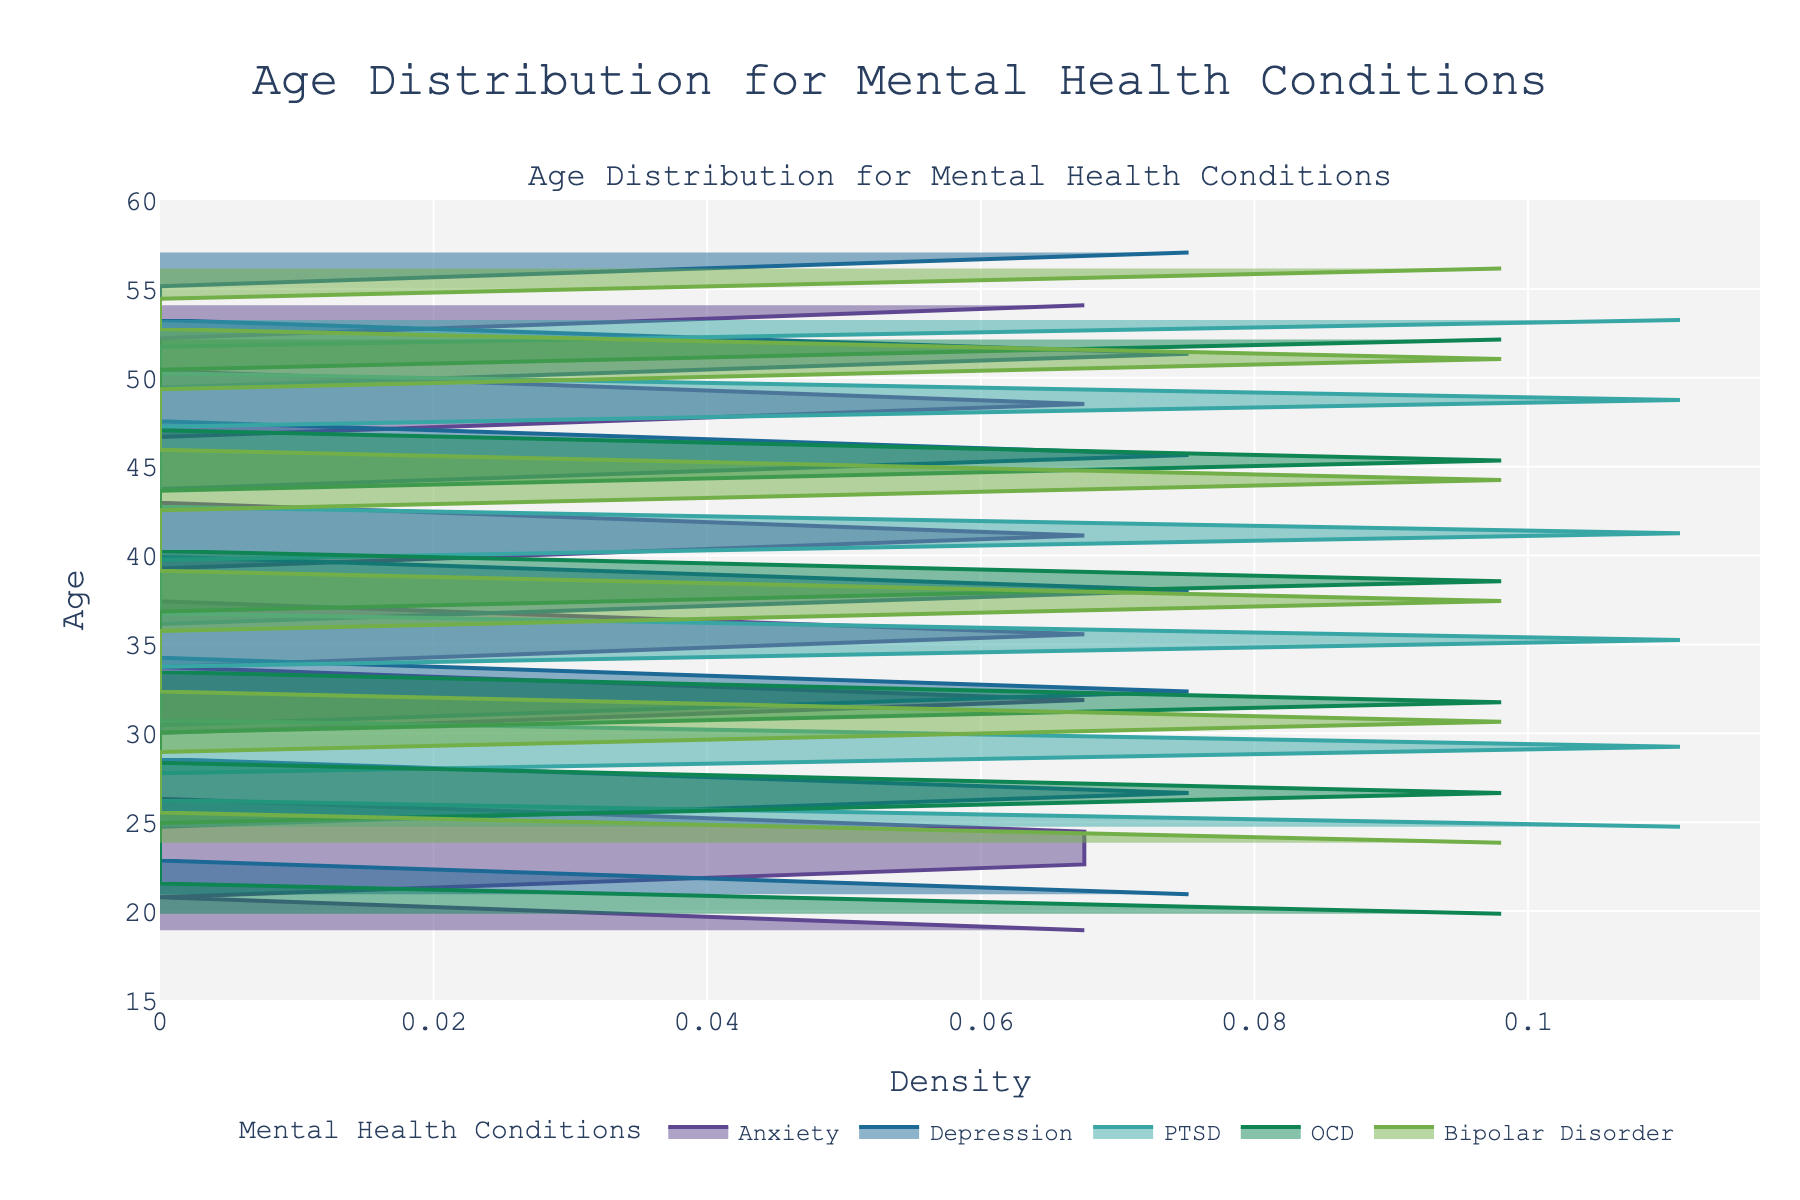What is the title of the figure? The title is displayed at the top of the figure in larger font. It is meant to provide a concise description of what the figure represents.
Answer: Age Distribution for Mental Health Conditions What is the age range displayed on the y-axis? The y-axis in the figure represents age, ranging from 15 to 60, as shown by the ticks and labels on the axis.
Answer: 15 to 60 Which mental health condition has the highest density peak? By examining the figure, one can observe the lines for each condition and find the one with the highest peak value in the density plot.
Answer: Anxiety How many major mental health conditions are represented in the figure? The legend at the bottom of the figure lists the mental health conditions being compared, showing five unique entries.
Answer: Five (Anxiety, Depression, PTSD, OCD, Bipolar Disorder) For which condition does the density peak around age 33? By analyzing the density plots, the condition whose density curve peaks around the age of 33 can be identified.
Answer: Depression How does the age distribution for PTSD compare to that of Bipolar Disorder? To compare the distributions, look at where the density peaks for each condition and their ages. PTSD peaks around mid-30s while Bipolar Disorder peaks around early-30s.
Answer: PTSD has an older age distribution compared to Bipolar Disorder Which condition shows the widest spread in age distribution? Look at the widths of the density plots. The condition with the densest, most extended curve indicates the widest age spread.
Answer: Anxiety Which condition has its density spread more evenly, suggesting a less pronounced peak? Analyzing the shapes of the density curves, identify the one that appears more like a broad hill rather than a steep peak.
Answer: OCD At what approximate age does Bipolar Disorder have a notable density peak? By focusing on the Bipolar Disorder's density plot, note the age range where the peak occurs.
Answer: Around 30 Is the density plot for Depression skewed towards younger or older ages? Check the shape of the density curve for Depression to see where it leans more densely. It mostly falls to the younger ages between early to mid 30s to early 40s.
Answer: Towards younger ages 